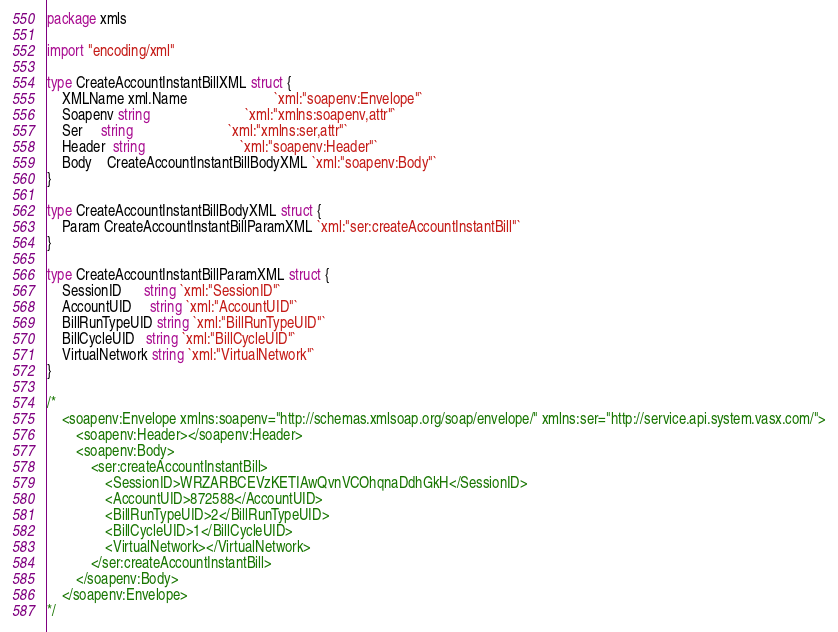Convert code to text. <code><loc_0><loc_0><loc_500><loc_500><_Go_>package xmls

import "encoding/xml"

type CreateAccountInstantBillXML struct {
	XMLName xml.Name                        `xml:"soapenv:Envelope"`
	Soapenv string                          `xml:"xmlns:soapenv,attr"`
	Ser     string                          `xml:"xmlns:ser,attr"`
	Header  string                          `xml:"soapenv:Header"`
	Body    CreateAccountInstantBillBodyXML `xml:"soapenv:Body"`
}

type CreateAccountInstantBillBodyXML struct {
	Param CreateAccountInstantBillParamXML `xml:"ser:createAccountInstantBill"`
}

type CreateAccountInstantBillParamXML struct {
	SessionID      string `xml:"SessionID"`
	AccountUID     string `xml:"AccountUID"`
	BillRunTypeUID string `xml:"BillRunTypeUID"`
	BillCycleUID   string `xml:"BillCycleUID"`
	VirtualNetwork string `xml:"VirtualNetwork"`
}

/*
	<soapenv:Envelope xmlns:soapenv="http://schemas.xmlsoap.org/soap/envelope/" xmlns:ser="http://service.api.system.vasx.com/">
		<soapenv:Header></soapenv:Header>
		<soapenv:Body>
			<ser:createAccountInstantBill>
				<SessionID>WRZARBCEVzKETIAwQvnVCOhqnaDdhGkH</SessionID>
				<AccountUID>872588</AccountUID>
				<BillRunTypeUID>2</BillRunTypeUID>
				<BillCycleUID>1</BillCycleUID>
				<VirtualNetwork></VirtualNetwork>
			</ser:createAccountInstantBill>
		</soapenv:Body>
	</soapenv:Envelope>
*/
</code> 